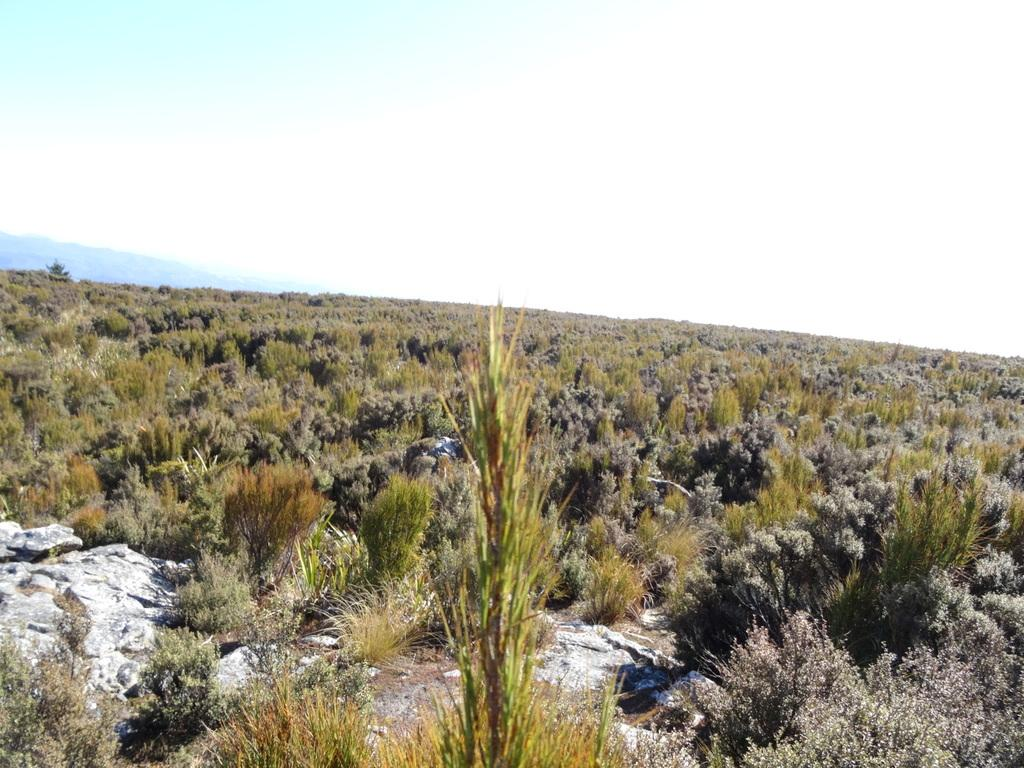Where was the image taken? The image was clicked outside the city. What can be seen in the center of the image? There are plants and grass in the center of the image. What is visible in the background of the image? There is a sky and hills visible in the background of the image. How many toes can be seen in the image? There are no toes visible in the image. Is there any steam coming out of the plants in the image? There is no steam present in the image. 